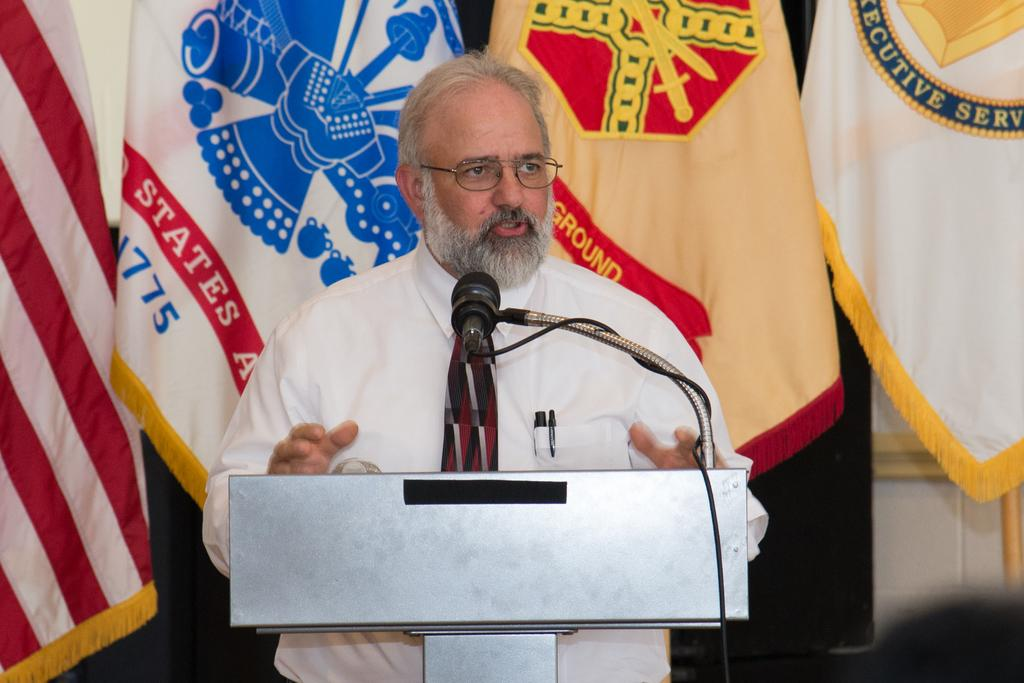<image>
Give a short and clear explanation of the subsequent image. A man is giving a speech at a Podium with a row of flags that says Executive Service. 